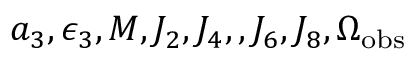Convert formula to latex. <formula><loc_0><loc_0><loc_500><loc_500>a _ { 3 } , \epsilon _ { 3 } , M , J _ { 2 } , J _ { 4 } , , J _ { 6 } , J _ { 8 } , \Omega _ { o b s }</formula> 